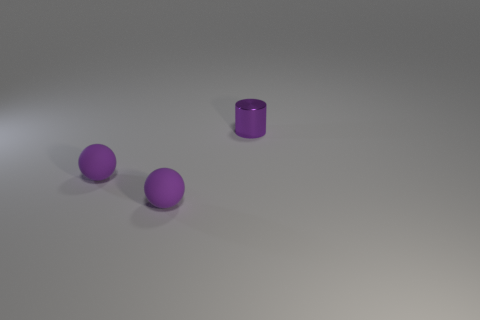Are there more purple cylinders than purple matte balls?
Offer a very short reply. No. What number of tiny spheres are the same color as the metallic thing?
Your response must be concise. 2. Is there anything else that is the same shape as the purple shiny object?
Give a very brief answer. No. How many matte objects are tiny blue spheres or purple cylinders?
Provide a succinct answer. 0. What material is the cylinder?
Provide a succinct answer. Metal. How many objects are tiny blue rubber blocks or small objects that are left of the purple metal object?
Ensure brevity in your answer.  2. How many blue things are tiny cylinders or rubber things?
Your response must be concise. 0. What size is the purple cylinder?
Make the answer very short. Small. Is the number of things left of the tiny cylinder greater than the number of brown matte things?
Your response must be concise. Yes. There is a cylinder; how many things are to the left of it?
Offer a terse response. 2. 